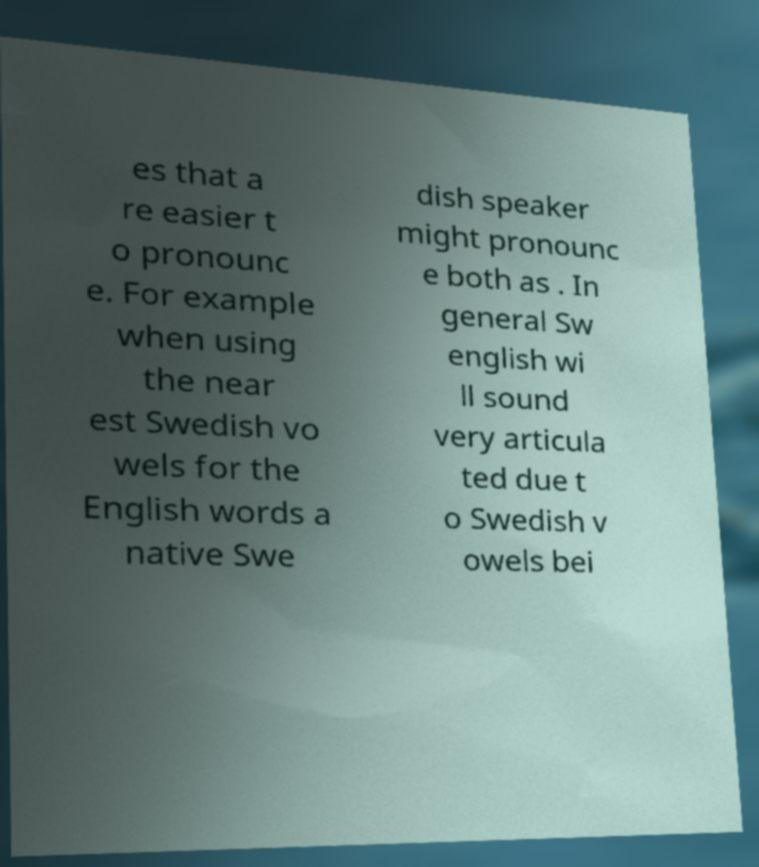Please read and relay the text visible in this image. What does it say? es that a re easier t o pronounc e. For example when using the near est Swedish vo wels for the English words a native Swe dish speaker might pronounc e both as . In general Sw english wi ll sound very articula ted due t o Swedish v owels bei 